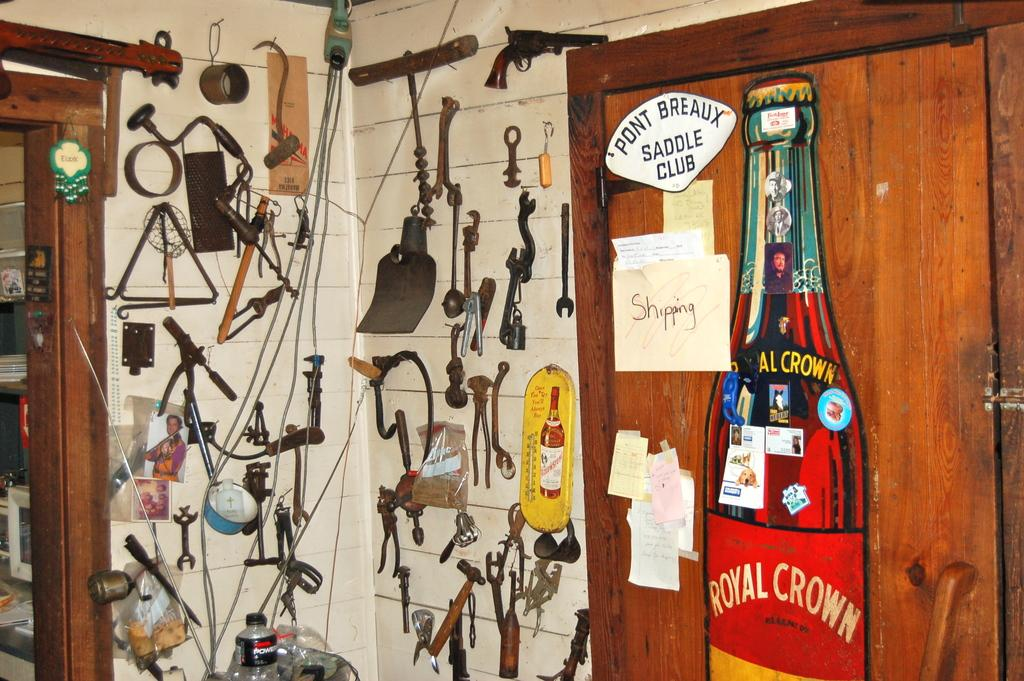<image>
Render a clear and concise summary of the photo. a royal crown ad that is on a red background 